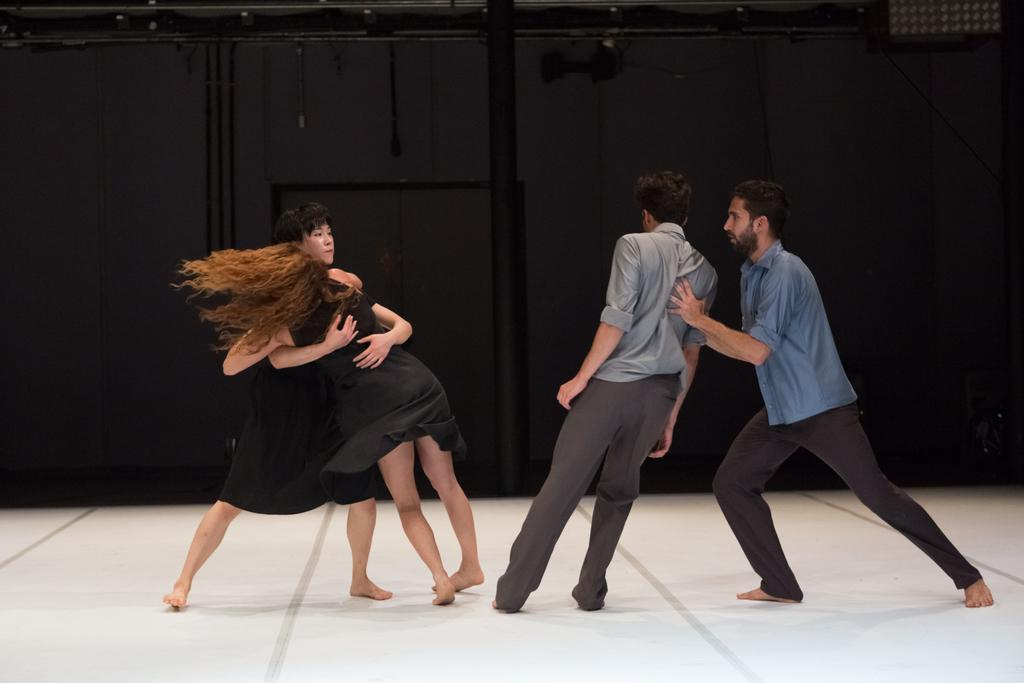How many people are in the image? There are four people in the image. What are the people doing in the image? The people are dancing on the floor. What can be seen behind the people in the image? There is a black wall in the background of the image. What is visible at the top of the image? There are objects visible at the top of the image. What type of grain is being harvested by the people in the image? There is no grain or harvesting activity depicted in the image; the people are dancing on the floor. What color is the skirt worn by the person on the left in the image? There is no skirt visible in the image, as the people are dancing and their clothing is not clearly discernible. 